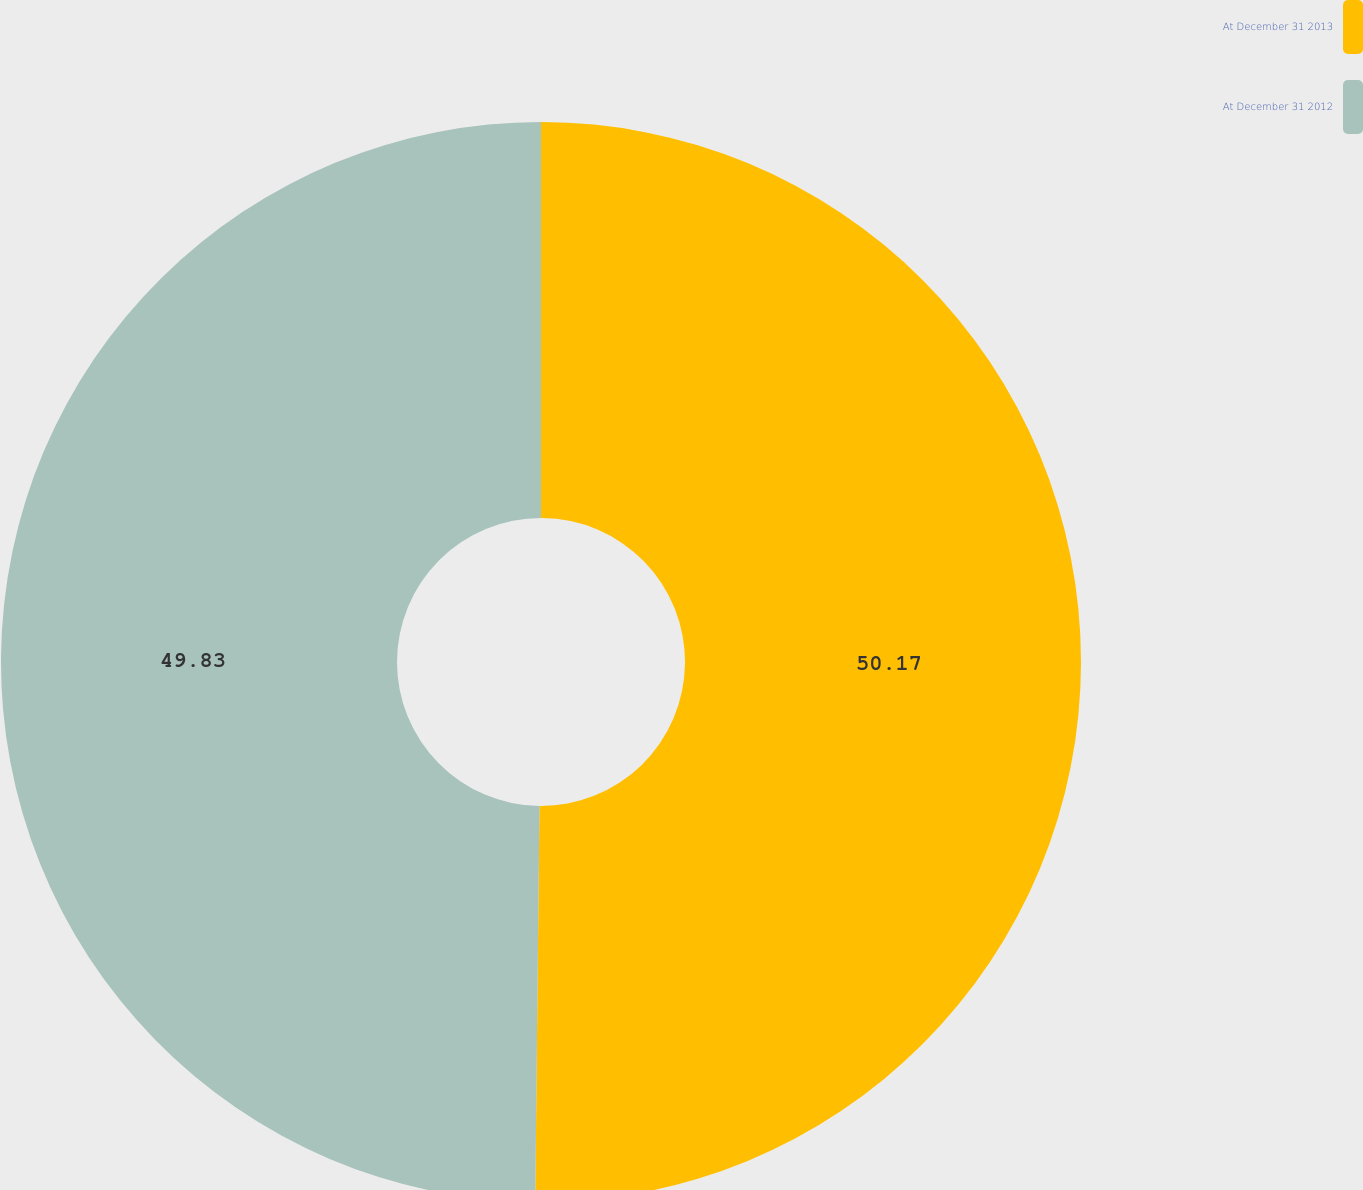Convert chart to OTSL. <chart><loc_0><loc_0><loc_500><loc_500><pie_chart><fcel>At December 31 2013<fcel>At December 31 2012<nl><fcel>50.17%<fcel>49.83%<nl></chart> 